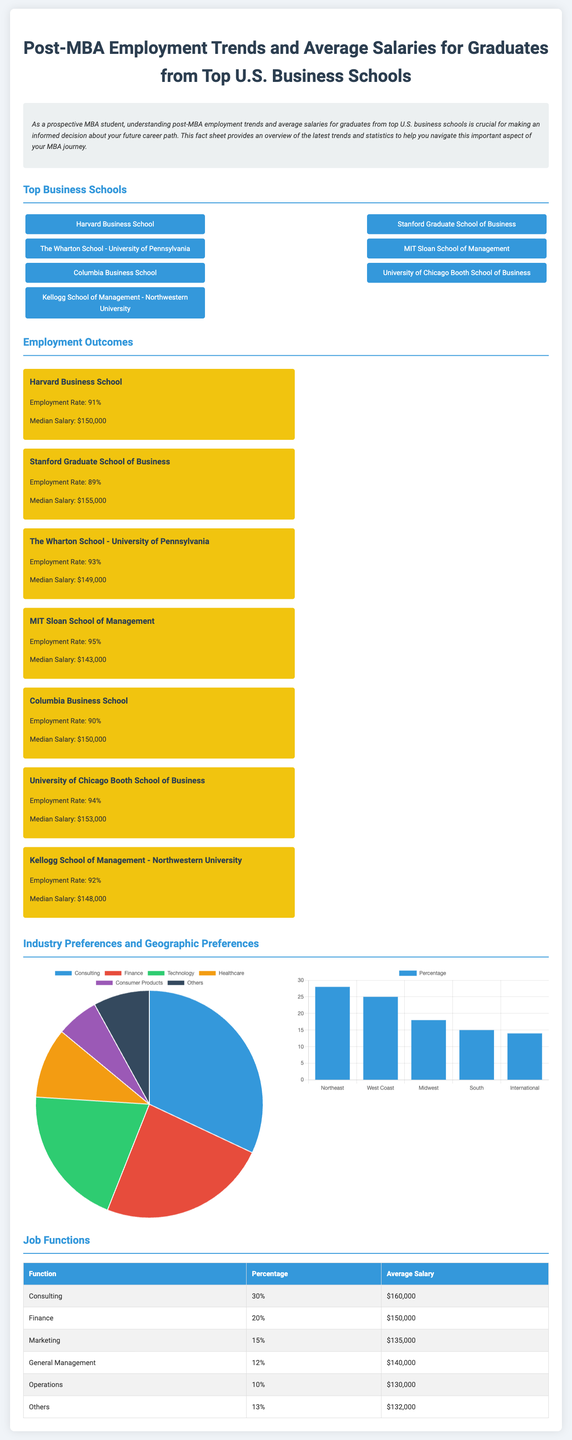What is the employment rate for Harvard Business School? The document states that the employment rate for Harvard Business School is 91%.
Answer: 91% What is the median salary for graduates from Stanford Graduate School of Business? According to the document, the median salary for Stanford graduates is $155,000.
Answer: $155,000 Which business school has the highest employment rate? The document lists MIT Sloan School of Management with the highest employment rate of 95%.
Answer: 95% What percentage of graduates enter the consulting field? The document indicates that 30% of graduates pursue consulting roles.
Answer: 30% What is the average salary for graduates in marketing? As per the document, the average salary for the marketing job function is $135,000.
Answer: $135,000 Which geographic region has the highest percentage preference for graduates? The document shows the Northeast region with a preference of 28%.
Answer: Northeast What is the total number of schools listed in the top business schools section? There are 7 schools listed in the top business schools section of the document.
Answer: 7 What is the average salary for graduates working in operations? The document states that the average salary for operations graduates is $130,000.
Answer: $130,000 